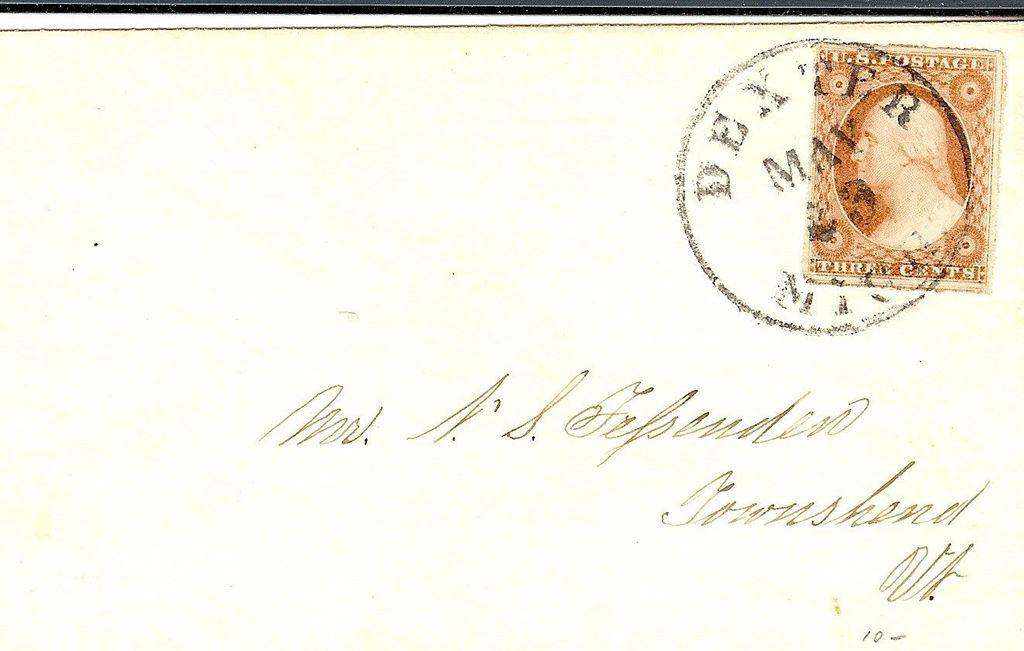<image>
Describe the image concisely. A letter that was postmarked from Dexter, MI in May 